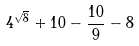<formula> <loc_0><loc_0><loc_500><loc_500>4 ^ { \sqrt { 8 } } + 1 0 - \frac { 1 0 } { 9 } - 8</formula> 